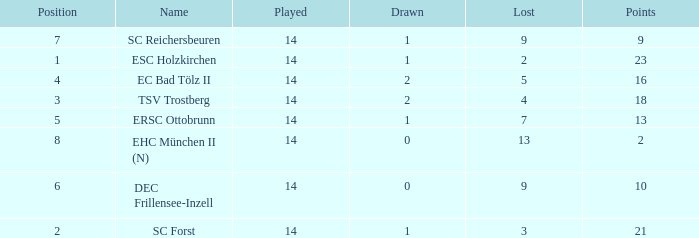How much Drawn has a Lost of 2, and Played smaller than 14? None. 